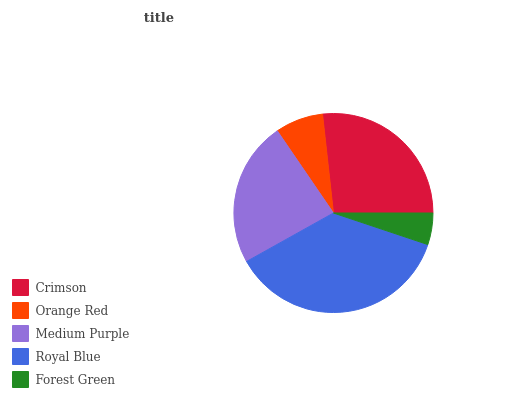Is Forest Green the minimum?
Answer yes or no. Yes. Is Royal Blue the maximum?
Answer yes or no. Yes. Is Orange Red the minimum?
Answer yes or no. No. Is Orange Red the maximum?
Answer yes or no. No. Is Crimson greater than Orange Red?
Answer yes or no. Yes. Is Orange Red less than Crimson?
Answer yes or no. Yes. Is Orange Red greater than Crimson?
Answer yes or no. No. Is Crimson less than Orange Red?
Answer yes or no. No. Is Medium Purple the high median?
Answer yes or no. Yes. Is Medium Purple the low median?
Answer yes or no. Yes. Is Crimson the high median?
Answer yes or no. No. Is Orange Red the low median?
Answer yes or no. No. 